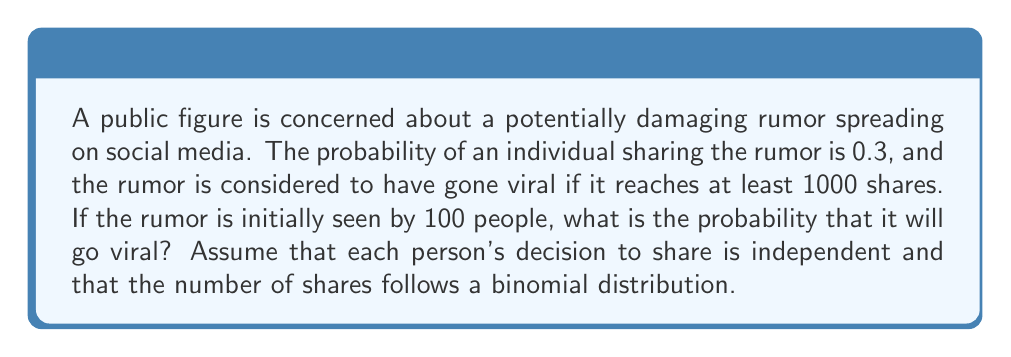Can you answer this question? To solve this problem, we need to use the binomial distribution and its normal approximation. Let's break it down step-by-step:

1) Let X be the random variable representing the number of shares.

2) We have:
   n = 100 (initial viewers)
   p = 0.3 (probability of sharing)
   We want P(X ≥ 1000)

3) For a binomial distribution:
   $$E(X) = np = 100 * 0.3 = 30$$
   $$Var(X) = np(1-p) = 100 * 0.3 * 0.7 = 21$$

4) Since n is large and np > 5, we can use the normal approximation to the binomial distribution.

5) We need to standardize our random variable:
   $$Z = \frac{X - np}{\sqrt{np(1-p)}}$$

6) Our threshold of 1000 shares becomes:
   $$Z = \frac{1000 - 30}{\sqrt{21}} \approx 211.67$$

7) We want P(X ≥ 1000) = P(Z ≥ 211.67)

8) Using a standard normal table or calculator, we find:
   P(Z ≥ 211.67) ≈ 0

9) Therefore, the probability of the rumor going viral (reaching at least 1000 shares) is essentially zero.

This extremely low probability is due to the large discrepancy between the expected number of shares (30) and the viral threshold (1000), given the initial conditions.
Answer: The probability that the rumor will go viral is approximately 0. 